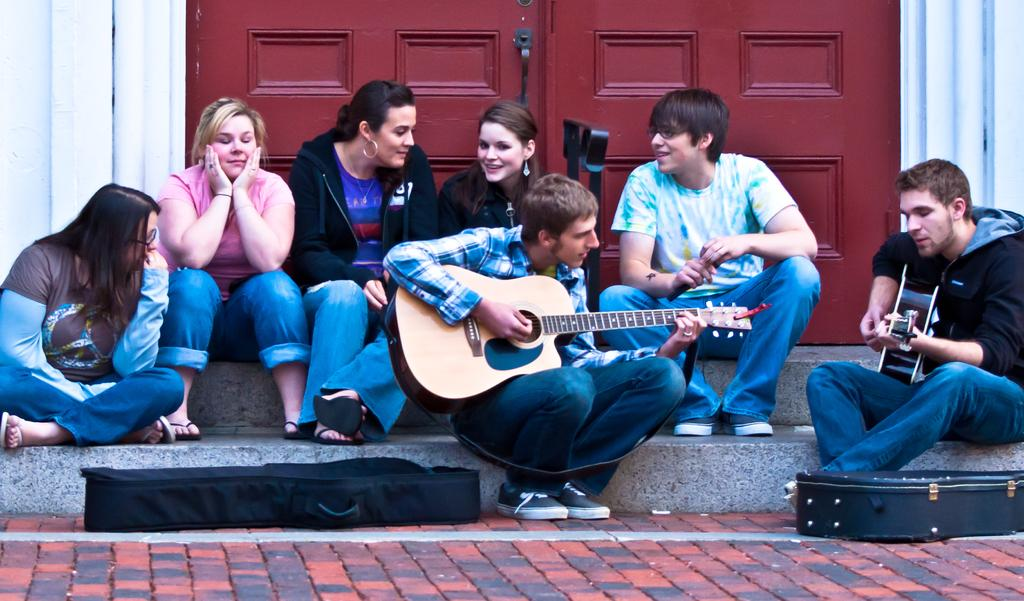What are the people in the image doing? The people in the image are sitting on stairs. What are two of the people holding? Two of the people are holding guitars. Can you describe the expressions on the faces of some people in the image? Some people have smiles on their faces. What can be seen in the background of the image? There is a door visible in the background of the image. What actor is performing in the image? There is no actor performing in the image; it shows people sitting on stairs and holding guitars. What type of gate can be seen in the image? There is no gate present in the image; it only features a door in the background. 